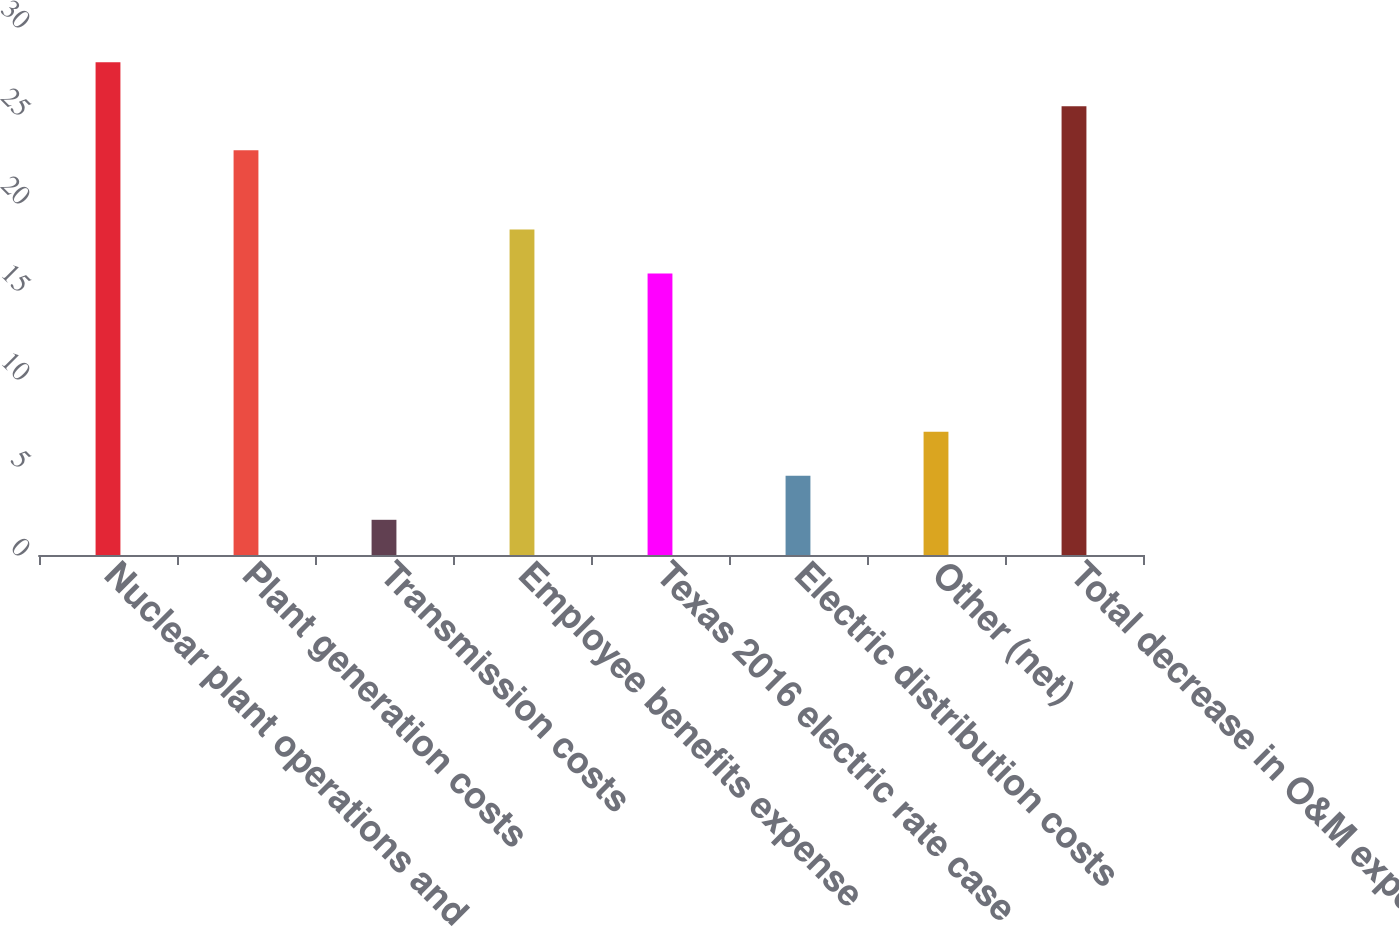<chart> <loc_0><loc_0><loc_500><loc_500><bar_chart><fcel>Nuclear plant operations and<fcel>Plant generation costs<fcel>Transmission costs<fcel>Employee benefits expense<fcel>Texas 2016 electric rate case<fcel>Electric distribution costs<fcel>Other (net)<fcel>Total decrease in O&M expenses<nl><fcel>28<fcel>23<fcel>2<fcel>18.5<fcel>16<fcel>4.5<fcel>7<fcel>25.5<nl></chart> 